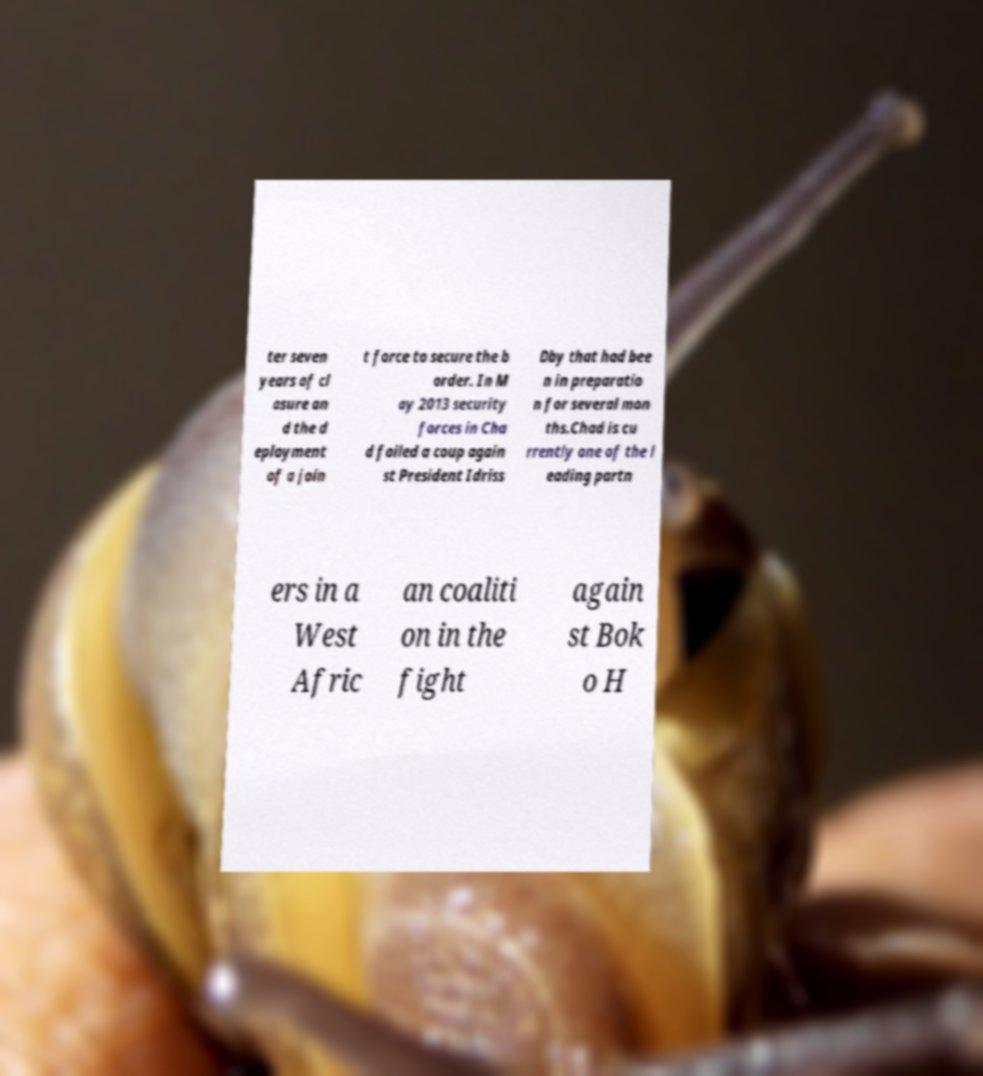I need the written content from this picture converted into text. Can you do that? ter seven years of cl osure an d the d eployment of a join t force to secure the b order. In M ay 2013 security forces in Cha d foiled a coup again st President Idriss Dby that had bee n in preparatio n for several mon ths.Chad is cu rrently one of the l eading partn ers in a West Afric an coaliti on in the fight again st Bok o H 